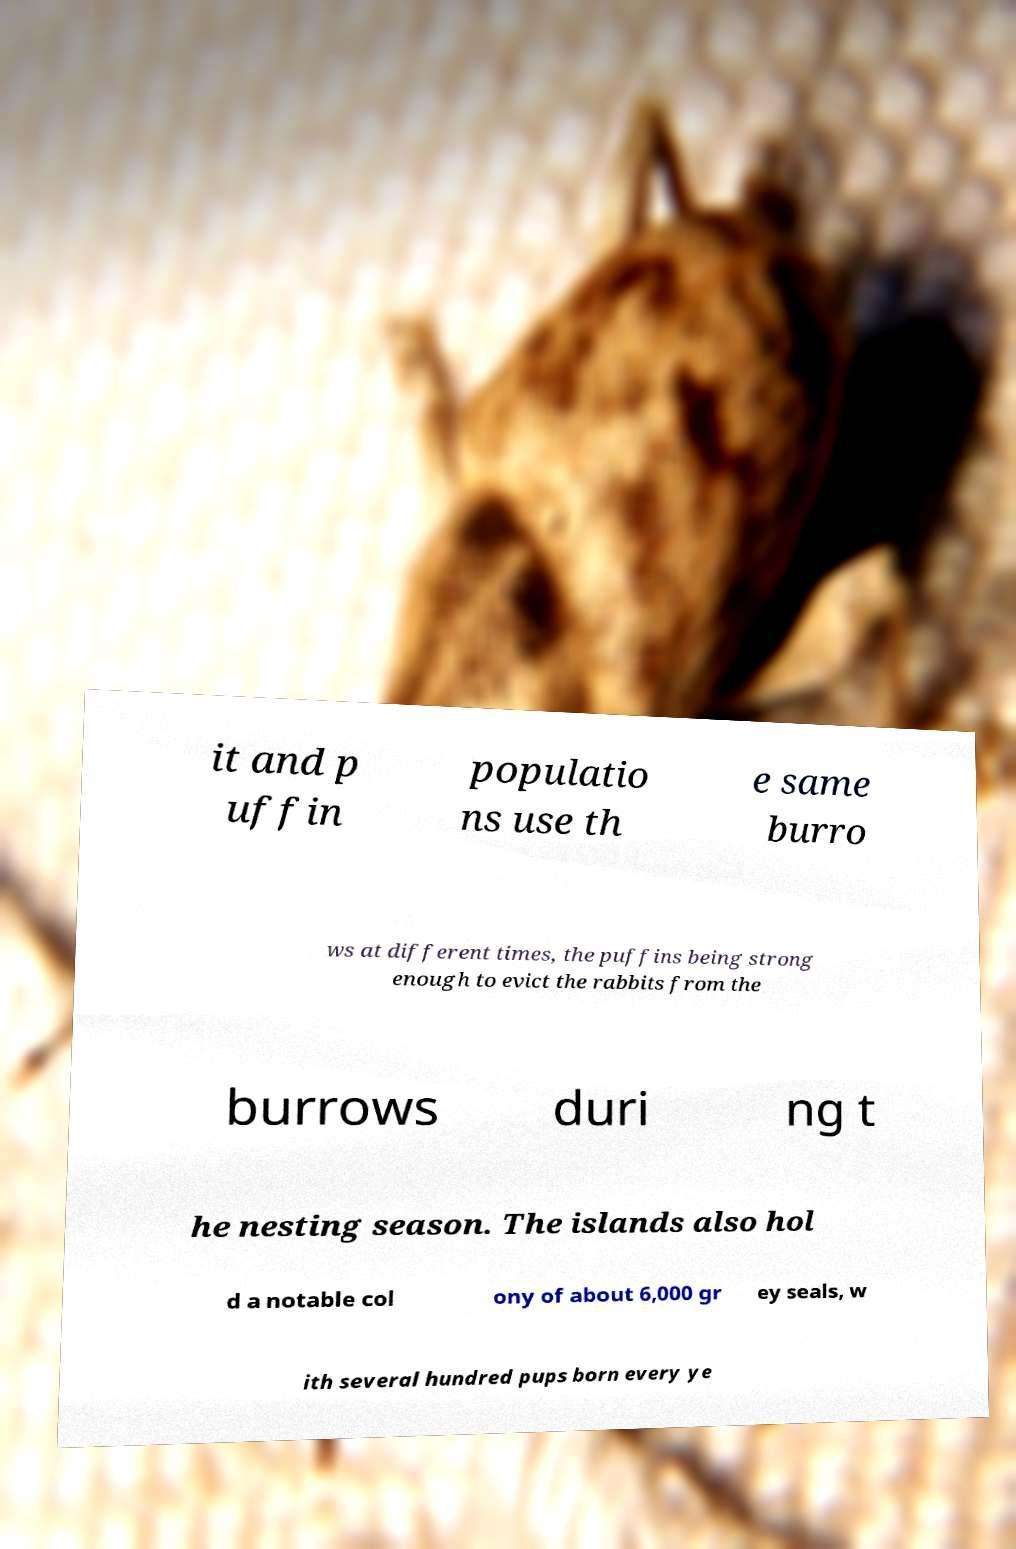Please identify and transcribe the text found in this image. it and p uffin populatio ns use th e same burro ws at different times, the puffins being strong enough to evict the rabbits from the burrows duri ng t he nesting season. The islands also hol d a notable col ony of about 6,000 gr ey seals, w ith several hundred pups born every ye 